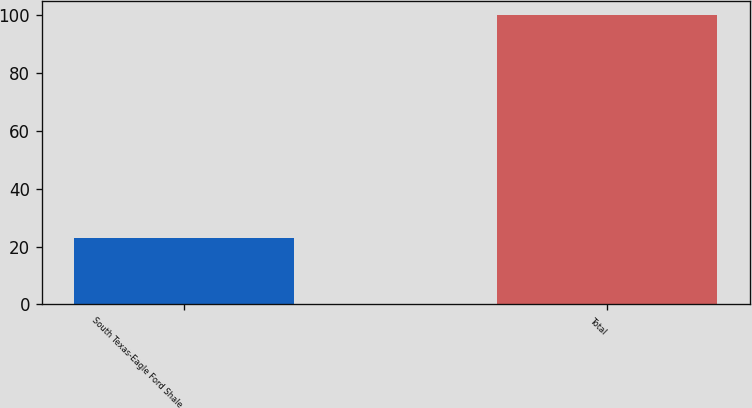<chart> <loc_0><loc_0><loc_500><loc_500><bar_chart><fcel>South Texas-Eagle Ford Shale<fcel>Total<nl><fcel>23<fcel>100<nl></chart> 